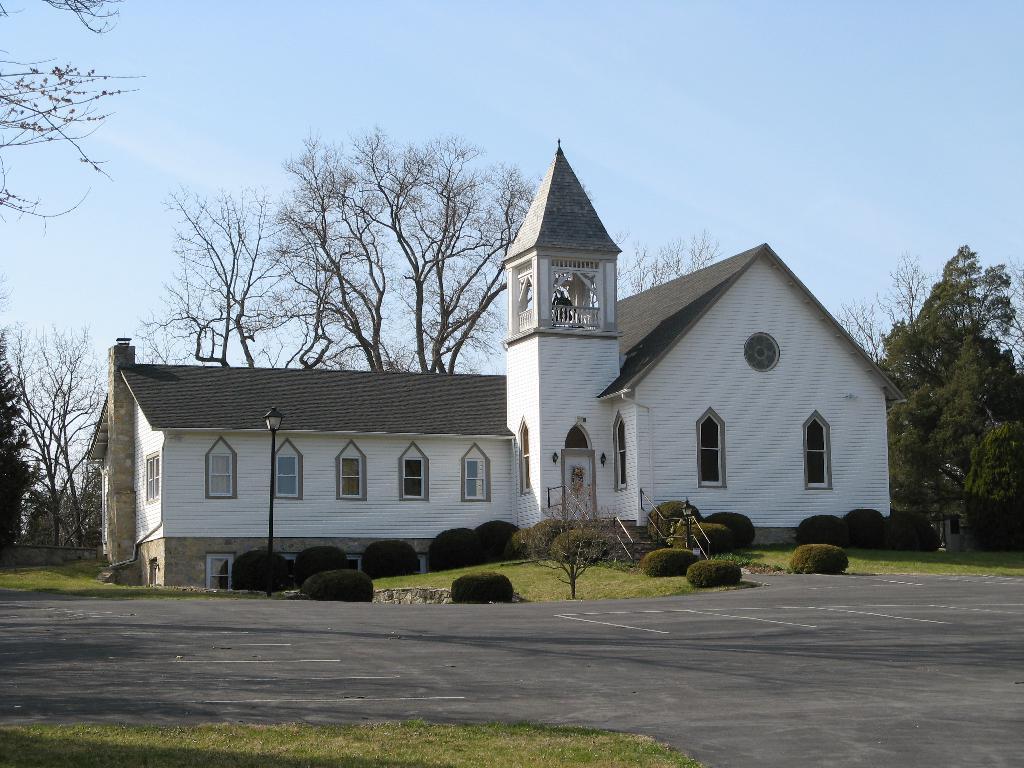Can you describe this image briefly? In this image in the center there is one house, plants, grass. At the bottom there is road and grass, and in the background there are trees. At the top there is sky. 